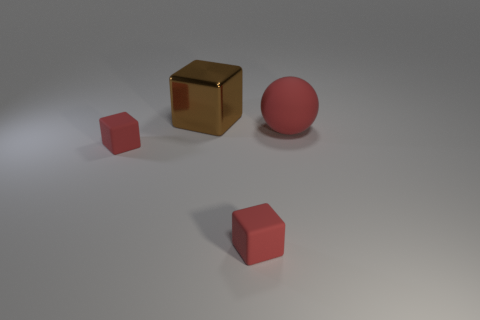Add 4 blue things. How many objects exist? 8 Subtract all blocks. How many objects are left? 1 Subtract 0 green balls. How many objects are left? 4 Subtract all tiny blocks. Subtract all tiny red things. How many objects are left? 0 Add 1 brown blocks. How many brown blocks are left? 2 Add 4 small purple metal blocks. How many small purple metal blocks exist? 4 